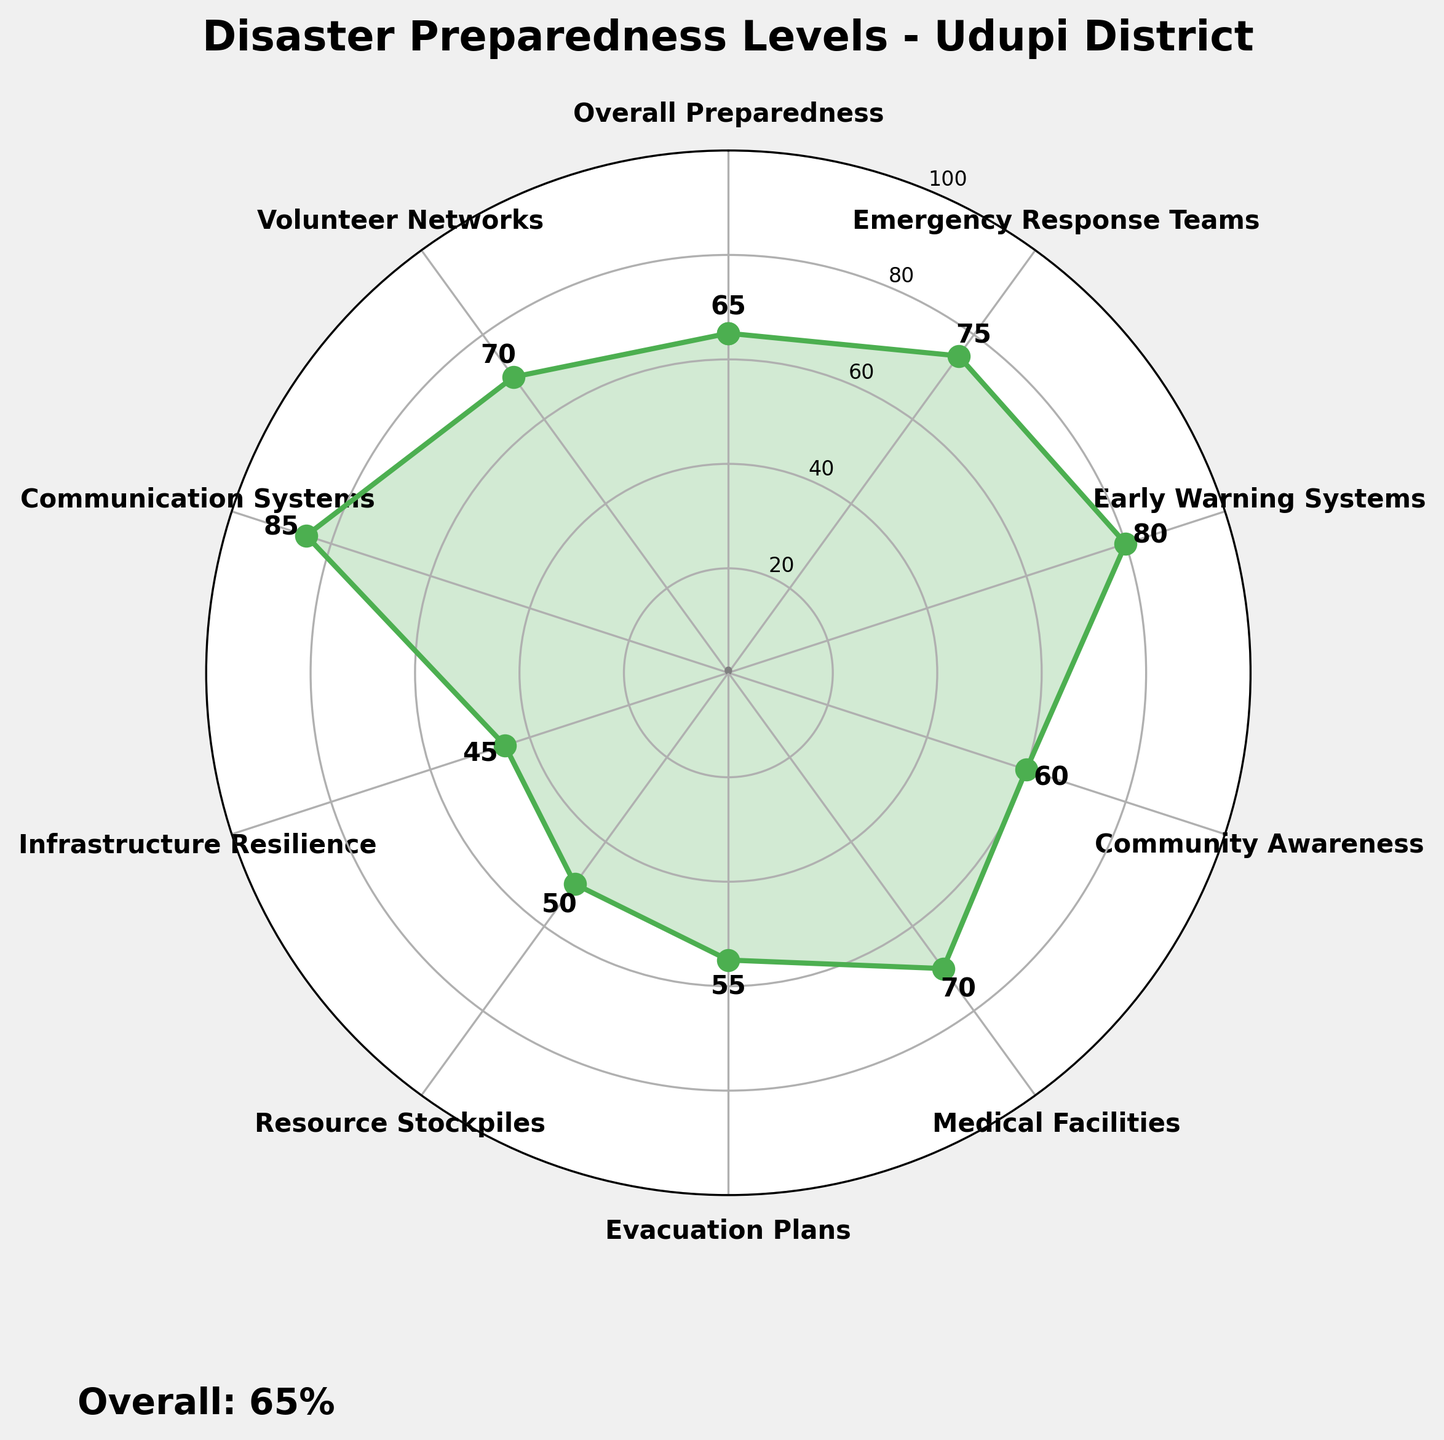How many categories are represented in the figure? The figure has labeled points for each category. Count the number of unique category labels.
Answer: 10 What is the title of the figure? The title is usually displayed at the top of the figure.
Answer: Disaster Preparedness Levels - Udupi District Which category has the lowest preparedness level? Look for the category with the smallest value on the axis.
Answer: Infrastructure Resilience What is the preparedness level of Emergency Response Teams? Locate the label "Emergency Response Teams" and read its value.
Answer: 75 Which category has the highest level of preparedness? Find the category with the highest value on the axis.
Answer: Communication Systems What is the overall preparedness level of the district? The overall preparedness value is often highlighted or mentioned separately in the figure.
Answer: 65 What is the difference between the preparedness levels of Medical Facilities and Resource Stockpiles? Subtract the value of Resource Stockpiles from the value of Medical Facilities.
Answer: 20 Is Community Awareness better prepared than Evacuation Plans? Compare the values of Community Awareness and Evacuation Plans.
Answer: Yes What is the average preparedness level of Emergency Response Teams, Medical Facilities, and Volunteer Networks? Sum the values of Emergency Response Teams (75), Medical Facilities (70), and Volunteer Networks (70) and divide by 3.
Answer: 71.67 How does the preparedness level of Early Warning Systems compare to Resource Stockpiles? Compare the values of Early Warning Systems (80) and Resource Stockpiles (50).
Answer: Early Warning Systems are more prepared What is the range of preparedness levels across all categories? Subtract the lowest value (Infrastructure Resilience, 45) from the highest value (Communication Systems, 85).
Answer: 40 